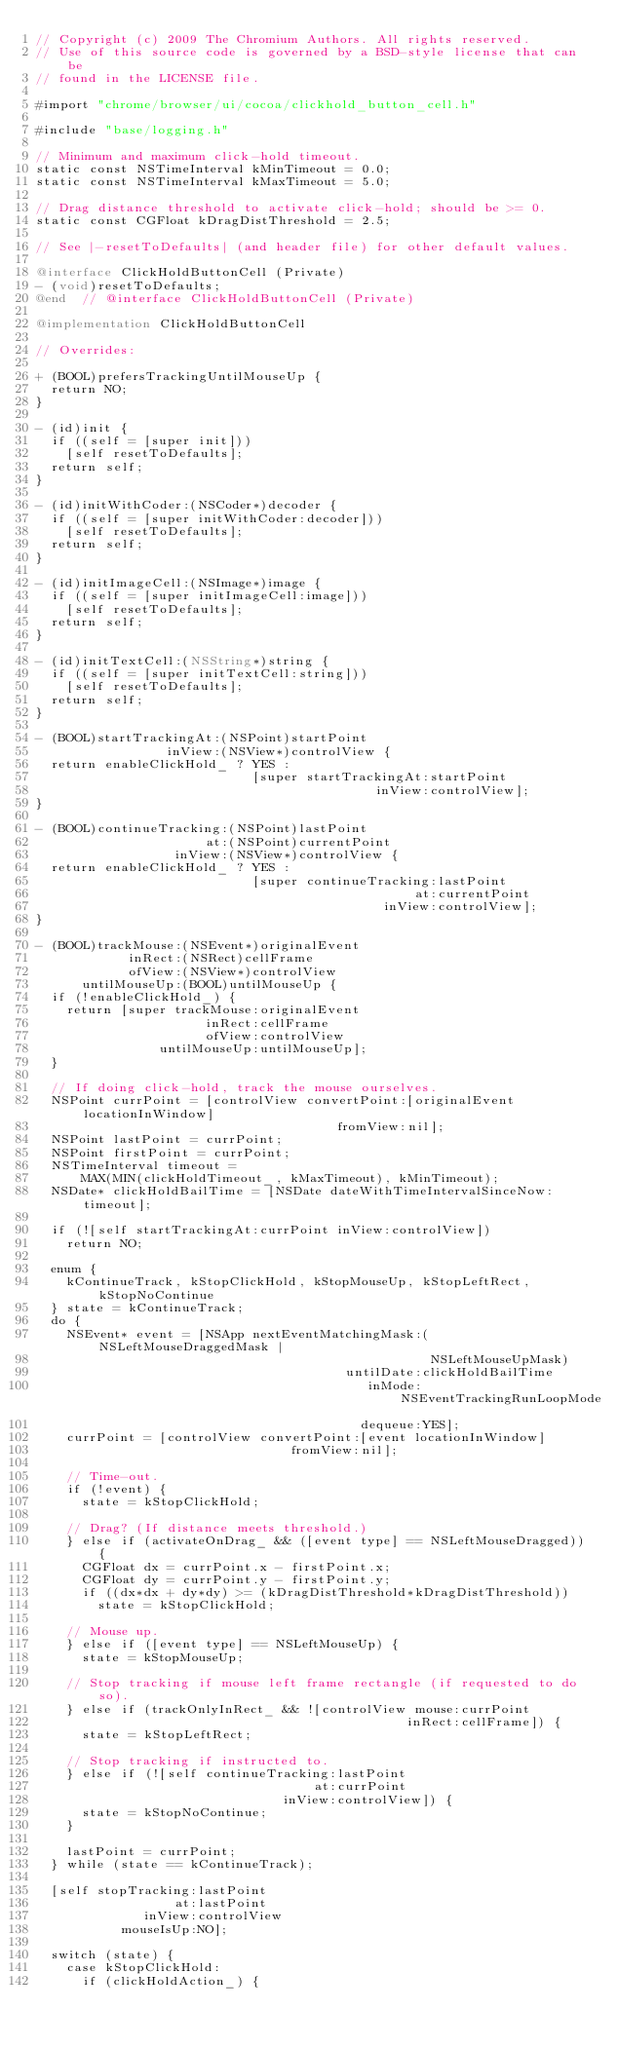<code> <loc_0><loc_0><loc_500><loc_500><_ObjectiveC_>// Copyright (c) 2009 The Chromium Authors. All rights reserved.
// Use of this source code is governed by a BSD-style license that can be
// found in the LICENSE file.

#import "chrome/browser/ui/cocoa/clickhold_button_cell.h"

#include "base/logging.h"

// Minimum and maximum click-hold timeout.
static const NSTimeInterval kMinTimeout = 0.0;
static const NSTimeInterval kMaxTimeout = 5.0;

// Drag distance threshold to activate click-hold; should be >= 0.
static const CGFloat kDragDistThreshold = 2.5;

// See |-resetToDefaults| (and header file) for other default values.

@interface ClickHoldButtonCell (Private)
- (void)resetToDefaults;
@end  // @interface ClickHoldButtonCell (Private)

@implementation ClickHoldButtonCell

// Overrides:

+ (BOOL)prefersTrackingUntilMouseUp {
  return NO;
}

- (id)init {
  if ((self = [super init]))
    [self resetToDefaults];
  return self;
}

- (id)initWithCoder:(NSCoder*)decoder {
  if ((self = [super initWithCoder:decoder]))
    [self resetToDefaults];
  return self;
}

- (id)initImageCell:(NSImage*)image {
  if ((self = [super initImageCell:image]))
    [self resetToDefaults];
  return self;
}

- (id)initTextCell:(NSString*)string {
  if ((self = [super initTextCell:string]))
    [self resetToDefaults];
  return self;
}

- (BOOL)startTrackingAt:(NSPoint)startPoint
                 inView:(NSView*)controlView {
  return enableClickHold_ ? YES :
                            [super startTrackingAt:startPoint
                                            inView:controlView];
}

- (BOOL)continueTracking:(NSPoint)lastPoint
                      at:(NSPoint)currentPoint
                  inView:(NSView*)controlView {
  return enableClickHold_ ? YES :
                            [super continueTracking:lastPoint
                                                 at:currentPoint
                                             inView:controlView];
}

- (BOOL)trackMouse:(NSEvent*)originalEvent
            inRect:(NSRect)cellFrame
            ofView:(NSView*)controlView
      untilMouseUp:(BOOL)untilMouseUp {
  if (!enableClickHold_) {
    return [super trackMouse:originalEvent
                      inRect:cellFrame
                      ofView:controlView
                untilMouseUp:untilMouseUp];
  }

  // If doing click-hold, track the mouse ourselves.
  NSPoint currPoint = [controlView convertPoint:[originalEvent locationInWindow]
                                       fromView:nil];
  NSPoint lastPoint = currPoint;
  NSPoint firstPoint = currPoint;
  NSTimeInterval timeout =
      MAX(MIN(clickHoldTimeout_, kMaxTimeout), kMinTimeout);
  NSDate* clickHoldBailTime = [NSDate dateWithTimeIntervalSinceNow:timeout];

  if (![self startTrackingAt:currPoint inView:controlView])
    return NO;

  enum {
    kContinueTrack, kStopClickHold, kStopMouseUp, kStopLeftRect, kStopNoContinue
  } state = kContinueTrack;
  do {
    NSEvent* event = [NSApp nextEventMatchingMask:(NSLeftMouseDraggedMask |
                                                   NSLeftMouseUpMask)
                                        untilDate:clickHoldBailTime
                                           inMode:NSEventTrackingRunLoopMode
                                          dequeue:YES];
    currPoint = [controlView convertPoint:[event locationInWindow]
                                 fromView:nil];

    // Time-out.
    if (!event) {
      state = kStopClickHold;

    // Drag? (If distance meets threshold.)
    } else if (activateOnDrag_ && ([event type] == NSLeftMouseDragged)) {
      CGFloat dx = currPoint.x - firstPoint.x;
      CGFloat dy = currPoint.y - firstPoint.y;
      if ((dx*dx + dy*dy) >= (kDragDistThreshold*kDragDistThreshold))
        state = kStopClickHold;

    // Mouse up.
    } else if ([event type] == NSLeftMouseUp) {
      state = kStopMouseUp;

    // Stop tracking if mouse left frame rectangle (if requested to do so).
    } else if (trackOnlyInRect_ && ![controlView mouse:currPoint
                                                inRect:cellFrame]) {
      state = kStopLeftRect;

    // Stop tracking if instructed to.
    } else if (![self continueTracking:lastPoint
                                    at:currPoint
                                inView:controlView]) {
      state = kStopNoContinue;
    }

    lastPoint = currPoint;
  } while (state == kContinueTrack);

  [self stopTracking:lastPoint
                  at:lastPoint
              inView:controlView
           mouseIsUp:NO];

  switch (state) {
    case kStopClickHold:
      if (clickHoldAction_) {</code> 